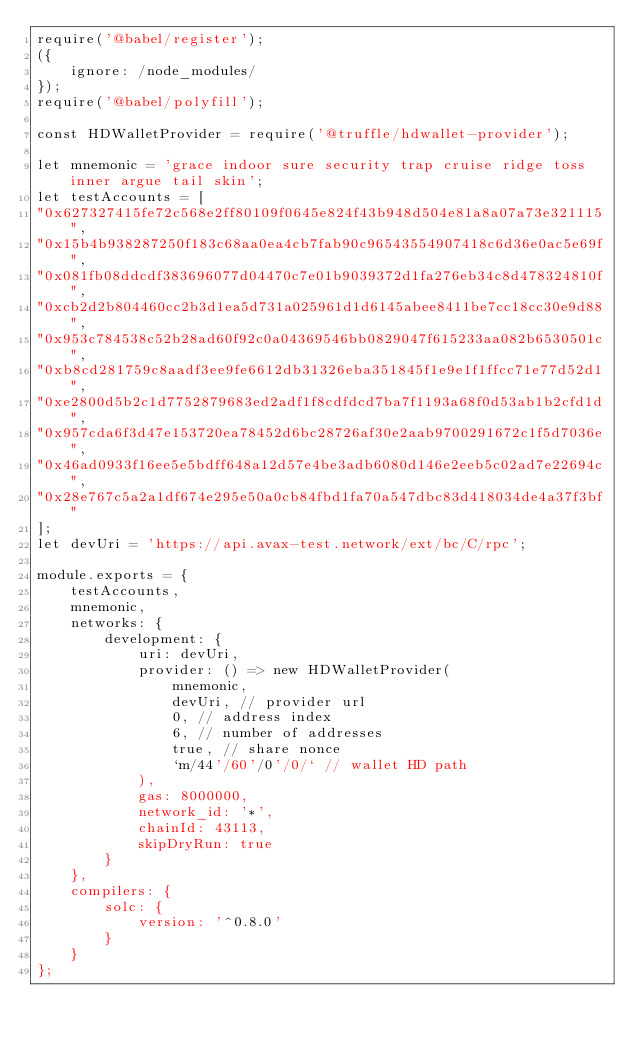<code> <loc_0><loc_0><loc_500><loc_500><_JavaScript_>require('@babel/register');
({
    ignore: /node_modules/
});
require('@babel/polyfill');

const HDWalletProvider = require('@truffle/hdwallet-provider');

let mnemonic = 'grace indoor sure security trap cruise ridge toss inner argue tail skin'; 
let testAccounts = [
"0x627327415fe72c568e2ff80109f0645e824f43b948d504e81a8a07a73e321115",
"0x15b4b938287250f183c68aa0ea4cb7fab90c96543554907418c6d36e0ac5e69f",
"0x081fb08ddcdf383696077d04470c7e01b9039372d1fa276eb34c8d478324810f",
"0xcb2d2b804460cc2b3d1ea5d731a025961d1d6145abee8411be7cc18cc30e9d88",
"0x953c784538c52b28ad60f92c0a04369546bb0829047f615233aa082b6530501c",
"0xb8cd281759c8aadf3ee9fe6612db31326eba351845f1e9e1f1ffcc71e77d52d1",
"0xe2800d5b2c1d7752879683ed2adf1f8cdfdcd7ba7f1193a68f0d53ab1b2cfd1d",
"0x957cda6f3d47e153720ea78452d6bc28726af30e2aab9700291672c1f5d7036e",
"0x46ad0933f16ee5e5bdff648a12d57e4be3adb6080d146e2eeb5c02ad7e22694c",
"0x28e767c5a2a1df674e295e50a0cb84fbd1fa70a547dbc83d418034de4a37f3bf"
]; 
let devUri = 'https://api.avax-test.network/ext/bc/C/rpc';

module.exports = {
    testAccounts,
    mnemonic,
    networks: {
        development: {
            uri: devUri,
            provider: () => new HDWalletProvider(
                mnemonic,
                devUri, // provider url
                0, // address index
                6, // number of addresses
                true, // share nonce
                `m/44'/60'/0'/0/` // wallet HD path
            ),
            gas: 8000000,
            network_id: '*',
            chainId: 43113,
            skipDryRun: true
        }
    },
    compilers: {
        solc: {
            version: '^0.8.0'
        }
    }
};


</code> 